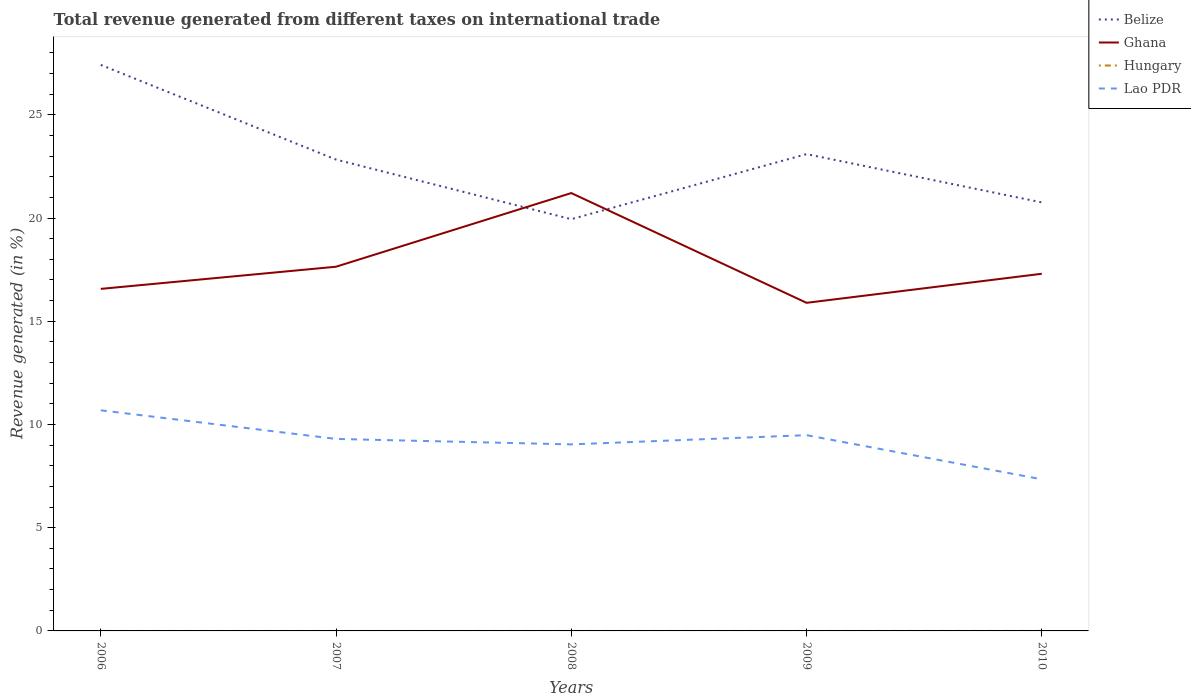Is the number of lines equal to the number of legend labels?
Your answer should be compact. No. Across all years, what is the maximum total revenue generated in Belize?
Make the answer very short. 19.94. What is the total total revenue generated in Lao PDR in the graph?
Provide a short and direct response. 1.96. What is the difference between the highest and the second highest total revenue generated in Belize?
Your answer should be very brief. 7.47. How many lines are there?
Provide a short and direct response. 3. Are the values on the major ticks of Y-axis written in scientific E-notation?
Your answer should be very brief. No. Does the graph contain any zero values?
Your answer should be compact. Yes. Does the graph contain grids?
Your answer should be compact. No. Where does the legend appear in the graph?
Offer a very short reply. Top right. How many legend labels are there?
Keep it short and to the point. 4. How are the legend labels stacked?
Your response must be concise. Vertical. What is the title of the graph?
Your answer should be very brief. Total revenue generated from different taxes on international trade. Does "Algeria" appear as one of the legend labels in the graph?
Provide a succinct answer. No. What is the label or title of the Y-axis?
Offer a very short reply. Revenue generated (in %). What is the Revenue generated (in %) of Belize in 2006?
Your answer should be very brief. 27.42. What is the Revenue generated (in %) in Ghana in 2006?
Your answer should be compact. 16.57. What is the Revenue generated (in %) of Lao PDR in 2006?
Your answer should be very brief. 10.69. What is the Revenue generated (in %) of Belize in 2007?
Provide a succinct answer. 22.83. What is the Revenue generated (in %) of Ghana in 2007?
Offer a very short reply. 17.64. What is the Revenue generated (in %) of Hungary in 2007?
Provide a succinct answer. 0. What is the Revenue generated (in %) in Lao PDR in 2007?
Provide a succinct answer. 9.3. What is the Revenue generated (in %) in Belize in 2008?
Offer a very short reply. 19.94. What is the Revenue generated (in %) of Ghana in 2008?
Provide a short and direct response. 21.21. What is the Revenue generated (in %) in Lao PDR in 2008?
Offer a terse response. 9.04. What is the Revenue generated (in %) of Belize in 2009?
Your answer should be very brief. 23.1. What is the Revenue generated (in %) in Ghana in 2009?
Make the answer very short. 15.89. What is the Revenue generated (in %) of Hungary in 2009?
Your answer should be very brief. 0. What is the Revenue generated (in %) in Lao PDR in 2009?
Offer a very short reply. 9.48. What is the Revenue generated (in %) in Belize in 2010?
Your response must be concise. 20.76. What is the Revenue generated (in %) in Ghana in 2010?
Your answer should be compact. 17.3. What is the Revenue generated (in %) of Hungary in 2010?
Your answer should be compact. 0. What is the Revenue generated (in %) of Lao PDR in 2010?
Provide a short and direct response. 7.34. Across all years, what is the maximum Revenue generated (in %) in Belize?
Your answer should be very brief. 27.42. Across all years, what is the maximum Revenue generated (in %) in Ghana?
Keep it short and to the point. 21.21. Across all years, what is the maximum Revenue generated (in %) in Lao PDR?
Provide a succinct answer. 10.69. Across all years, what is the minimum Revenue generated (in %) of Belize?
Offer a terse response. 19.94. Across all years, what is the minimum Revenue generated (in %) of Ghana?
Keep it short and to the point. 15.89. Across all years, what is the minimum Revenue generated (in %) of Lao PDR?
Make the answer very short. 7.34. What is the total Revenue generated (in %) of Belize in the graph?
Offer a very short reply. 114.04. What is the total Revenue generated (in %) in Ghana in the graph?
Keep it short and to the point. 88.61. What is the total Revenue generated (in %) of Hungary in the graph?
Your response must be concise. 0. What is the total Revenue generated (in %) of Lao PDR in the graph?
Provide a succinct answer. 45.85. What is the difference between the Revenue generated (in %) of Belize in 2006 and that in 2007?
Provide a succinct answer. 4.59. What is the difference between the Revenue generated (in %) of Ghana in 2006 and that in 2007?
Keep it short and to the point. -1.07. What is the difference between the Revenue generated (in %) in Lao PDR in 2006 and that in 2007?
Give a very brief answer. 1.39. What is the difference between the Revenue generated (in %) in Belize in 2006 and that in 2008?
Provide a succinct answer. 7.47. What is the difference between the Revenue generated (in %) of Ghana in 2006 and that in 2008?
Provide a short and direct response. -4.64. What is the difference between the Revenue generated (in %) of Lao PDR in 2006 and that in 2008?
Provide a short and direct response. 1.65. What is the difference between the Revenue generated (in %) in Belize in 2006 and that in 2009?
Provide a succinct answer. 4.32. What is the difference between the Revenue generated (in %) in Ghana in 2006 and that in 2009?
Offer a very short reply. 0.68. What is the difference between the Revenue generated (in %) in Lao PDR in 2006 and that in 2009?
Offer a terse response. 1.2. What is the difference between the Revenue generated (in %) of Belize in 2006 and that in 2010?
Your answer should be compact. 6.66. What is the difference between the Revenue generated (in %) of Ghana in 2006 and that in 2010?
Provide a succinct answer. -0.73. What is the difference between the Revenue generated (in %) in Lao PDR in 2006 and that in 2010?
Ensure brevity in your answer.  3.34. What is the difference between the Revenue generated (in %) of Belize in 2007 and that in 2008?
Give a very brief answer. 2.89. What is the difference between the Revenue generated (in %) of Ghana in 2007 and that in 2008?
Offer a very short reply. -3.57. What is the difference between the Revenue generated (in %) of Lao PDR in 2007 and that in 2008?
Offer a terse response. 0.27. What is the difference between the Revenue generated (in %) of Belize in 2007 and that in 2009?
Offer a very short reply. -0.27. What is the difference between the Revenue generated (in %) in Ghana in 2007 and that in 2009?
Your answer should be compact. 1.75. What is the difference between the Revenue generated (in %) in Lao PDR in 2007 and that in 2009?
Your answer should be compact. -0.18. What is the difference between the Revenue generated (in %) in Belize in 2007 and that in 2010?
Your answer should be very brief. 2.07. What is the difference between the Revenue generated (in %) of Ghana in 2007 and that in 2010?
Your response must be concise. 0.34. What is the difference between the Revenue generated (in %) in Lao PDR in 2007 and that in 2010?
Provide a short and direct response. 1.96. What is the difference between the Revenue generated (in %) of Belize in 2008 and that in 2009?
Provide a succinct answer. -3.15. What is the difference between the Revenue generated (in %) of Ghana in 2008 and that in 2009?
Give a very brief answer. 5.32. What is the difference between the Revenue generated (in %) in Lao PDR in 2008 and that in 2009?
Keep it short and to the point. -0.45. What is the difference between the Revenue generated (in %) in Belize in 2008 and that in 2010?
Your answer should be compact. -0.81. What is the difference between the Revenue generated (in %) of Ghana in 2008 and that in 2010?
Keep it short and to the point. 3.91. What is the difference between the Revenue generated (in %) in Lao PDR in 2008 and that in 2010?
Your answer should be very brief. 1.69. What is the difference between the Revenue generated (in %) in Belize in 2009 and that in 2010?
Provide a short and direct response. 2.34. What is the difference between the Revenue generated (in %) of Ghana in 2009 and that in 2010?
Offer a very short reply. -1.41. What is the difference between the Revenue generated (in %) in Lao PDR in 2009 and that in 2010?
Offer a terse response. 2.14. What is the difference between the Revenue generated (in %) of Belize in 2006 and the Revenue generated (in %) of Ghana in 2007?
Ensure brevity in your answer.  9.78. What is the difference between the Revenue generated (in %) in Belize in 2006 and the Revenue generated (in %) in Lao PDR in 2007?
Your answer should be very brief. 18.12. What is the difference between the Revenue generated (in %) of Ghana in 2006 and the Revenue generated (in %) of Lao PDR in 2007?
Your response must be concise. 7.27. What is the difference between the Revenue generated (in %) of Belize in 2006 and the Revenue generated (in %) of Ghana in 2008?
Give a very brief answer. 6.21. What is the difference between the Revenue generated (in %) in Belize in 2006 and the Revenue generated (in %) in Lao PDR in 2008?
Keep it short and to the point. 18.38. What is the difference between the Revenue generated (in %) in Ghana in 2006 and the Revenue generated (in %) in Lao PDR in 2008?
Ensure brevity in your answer.  7.53. What is the difference between the Revenue generated (in %) of Belize in 2006 and the Revenue generated (in %) of Ghana in 2009?
Offer a terse response. 11.53. What is the difference between the Revenue generated (in %) of Belize in 2006 and the Revenue generated (in %) of Lao PDR in 2009?
Offer a terse response. 17.94. What is the difference between the Revenue generated (in %) in Ghana in 2006 and the Revenue generated (in %) in Lao PDR in 2009?
Provide a short and direct response. 7.09. What is the difference between the Revenue generated (in %) in Belize in 2006 and the Revenue generated (in %) in Ghana in 2010?
Your response must be concise. 10.12. What is the difference between the Revenue generated (in %) of Belize in 2006 and the Revenue generated (in %) of Lao PDR in 2010?
Ensure brevity in your answer.  20.07. What is the difference between the Revenue generated (in %) in Ghana in 2006 and the Revenue generated (in %) in Lao PDR in 2010?
Offer a very short reply. 9.22. What is the difference between the Revenue generated (in %) in Belize in 2007 and the Revenue generated (in %) in Ghana in 2008?
Ensure brevity in your answer.  1.62. What is the difference between the Revenue generated (in %) in Belize in 2007 and the Revenue generated (in %) in Lao PDR in 2008?
Your answer should be compact. 13.8. What is the difference between the Revenue generated (in %) in Ghana in 2007 and the Revenue generated (in %) in Lao PDR in 2008?
Your answer should be very brief. 8.61. What is the difference between the Revenue generated (in %) of Belize in 2007 and the Revenue generated (in %) of Ghana in 2009?
Keep it short and to the point. 6.94. What is the difference between the Revenue generated (in %) in Belize in 2007 and the Revenue generated (in %) in Lao PDR in 2009?
Your answer should be compact. 13.35. What is the difference between the Revenue generated (in %) of Ghana in 2007 and the Revenue generated (in %) of Lao PDR in 2009?
Provide a succinct answer. 8.16. What is the difference between the Revenue generated (in %) in Belize in 2007 and the Revenue generated (in %) in Ghana in 2010?
Your answer should be very brief. 5.53. What is the difference between the Revenue generated (in %) of Belize in 2007 and the Revenue generated (in %) of Lao PDR in 2010?
Your answer should be very brief. 15.49. What is the difference between the Revenue generated (in %) in Ghana in 2007 and the Revenue generated (in %) in Lao PDR in 2010?
Your answer should be compact. 10.3. What is the difference between the Revenue generated (in %) in Belize in 2008 and the Revenue generated (in %) in Ghana in 2009?
Provide a short and direct response. 4.05. What is the difference between the Revenue generated (in %) in Belize in 2008 and the Revenue generated (in %) in Lao PDR in 2009?
Your response must be concise. 10.46. What is the difference between the Revenue generated (in %) in Ghana in 2008 and the Revenue generated (in %) in Lao PDR in 2009?
Provide a short and direct response. 11.73. What is the difference between the Revenue generated (in %) of Belize in 2008 and the Revenue generated (in %) of Ghana in 2010?
Give a very brief answer. 2.64. What is the difference between the Revenue generated (in %) of Belize in 2008 and the Revenue generated (in %) of Lao PDR in 2010?
Offer a terse response. 12.6. What is the difference between the Revenue generated (in %) in Ghana in 2008 and the Revenue generated (in %) in Lao PDR in 2010?
Provide a short and direct response. 13.86. What is the difference between the Revenue generated (in %) in Belize in 2009 and the Revenue generated (in %) in Ghana in 2010?
Your answer should be compact. 5.8. What is the difference between the Revenue generated (in %) in Belize in 2009 and the Revenue generated (in %) in Lao PDR in 2010?
Offer a very short reply. 15.75. What is the difference between the Revenue generated (in %) of Ghana in 2009 and the Revenue generated (in %) of Lao PDR in 2010?
Ensure brevity in your answer.  8.55. What is the average Revenue generated (in %) in Belize per year?
Make the answer very short. 22.81. What is the average Revenue generated (in %) in Ghana per year?
Provide a succinct answer. 17.72. What is the average Revenue generated (in %) of Lao PDR per year?
Make the answer very short. 9.17. In the year 2006, what is the difference between the Revenue generated (in %) in Belize and Revenue generated (in %) in Ghana?
Your answer should be compact. 10.85. In the year 2006, what is the difference between the Revenue generated (in %) in Belize and Revenue generated (in %) in Lao PDR?
Ensure brevity in your answer.  16.73. In the year 2006, what is the difference between the Revenue generated (in %) in Ghana and Revenue generated (in %) in Lao PDR?
Your answer should be very brief. 5.88. In the year 2007, what is the difference between the Revenue generated (in %) in Belize and Revenue generated (in %) in Ghana?
Your answer should be very brief. 5.19. In the year 2007, what is the difference between the Revenue generated (in %) of Belize and Revenue generated (in %) of Lao PDR?
Your answer should be compact. 13.53. In the year 2007, what is the difference between the Revenue generated (in %) in Ghana and Revenue generated (in %) in Lao PDR?
Provide a short and direct response. 8.34. In the year 2008, what is the difference between the Revenue generated (in %) of Belize and Revenue generated (in %) of Ghana?
Ensure brevity in your answer.  -1.27. In the year 2008, what is the difference between the Revenue generated (in %) in Belize and Revenue generated (in %) in Lao PDR?
Provide a short and direct response. 10.91. In the year 2008, what is the difference between the Revenue generated (in %) in Ghana and Revenue generated (in %) in Lao PDR?
Your answer should be very brief. 12.17. In the year 2009, what is the difference between the Revenue generated (in %) of Belize and Revenue generated (in %) of Ghana?
Your answer should be compact. 7.2. In the year 2009, what is the difference between the Revenue generated (in %) in Belize and Revenue generated (in %) in Lao PDR?
Ensure brevity in your answer.  13.61. In the year 2009, what is the difference between the Revenue generated (in %) of Ghana and Revenue generated (in %) of Lao PDR?
Keep it short and to the point. 6.41. In the year 2010, what is the difference between the Revenue generated (in %) in Belize and Revenue generated (in %) in Ghana?
Keep it short and to the point. 3.46. In the year 2010, what is the difference between the Revenue generated (in %) of Belize and Revenue generated (in %) of Lao PDR?
Provide a succinct answer. 13.41. In the year 2010, what is the difference between the Revenue generated (in %) in Ghana and Revenue generated (in %) in Lao PDR?
Your response must be concise. 9.96. What is the ratio of the Revenue generated (in %) in Belize in 2006 to that in 2007?
Offer a very short reply. 1.2. What is the ratio of the Revenue generated (in %) of Ghana in 2006 to that in 2007?
Offer a very short reply. 0.94. What is the ratio of the Revenue generated (in %) in Lao PDR in 2006 to that in 2007?
Your response must be concise. 1.15. What is the ratio of the Revenue generated (in %) in Belize in 2006 to that in 2008?
Keep it short and to the point. 1.37. What is the ratio of the Revenue generated (in %) of Ghana in 2006 to that in 2008?
Provide a succinct answer. 0.78. What is the ratio of the Revenue generated (in %) in Lao PDR in 2006 to that in 2008?
Keep it short and to the point. 1.18. What is the ratio of the Revenue generated (in %) of Belize in 2006 to that in 2009?
Keep it short and to the point. 1.19. What is the ratio of the Revenue generated (in %) of Ghana in 2006 to that in 2009?
Your answer should be compact. 1.04. What is the ratio of the Revenue generated (in %) of Lao PDR in 2006 to that in 2009?
Your answer should be compact. 1.13. What is the ratio of the Revenue generated (in %) of Belize in 2006 to that in 2010?
Your response must be concise. 1.32. What is the ratio of the Revenue generated (in %) in Ghana in 2006 to that in 2010?
Provide a short and direct response. 0.96. What is the ratio of the Revenue generated (in %) in Lao PDR in 2006 to that in 2010?
Give a very brief answer. 1.45. What is the ratio of the Revenue generated (in %) in Belize in 2007 to that in 2008?
Provide a succinct answer. 1.14. What is the ratio of the Revenue generated (in %) of Ghana in 2007 to that in 2008?
Make the answer very short. 0.83. What is the ratio of the Revenue generated (in %) of Lao PDR in 2007 to that in 2008?
Keep it short and to the point. 1.03. What is the ratio of the Revenue generated (in %) in Belize in 2007 to that in 2009?
Provide a succinct answer. 0.99. What is the ratio of the Revenue generated (in %) of Ghana in 2007 to that in 2009?
Your answer should be compact. 1.11. What is the ratio of the Revenue generated (in %) of Lao PDR in 2007 to that in 2009?
Offer a terse response. 0.98. What is the ratio of the Revenue generated (in %) in Belize in 2007 to that in 2010?
Make the answer very short. 1.1. What is the ratio of the Revenue generated (in %) of Ghana in 2007 to that in 2010?
Give a very brief answer. 1.02. What is the ratio of the Revenue generated (in %) in Lao PDR in 2007 to that in 2010?
Provide a succinct answer. 1.27. What is the ratio of the Revenue generated (in %) of Belize in 2008 to that in 2009?
Make the answer very short. 0.86. What is the ratio of the Revenue generated (in %) in Ghana in 2008 to that in 2009?
Offer a terse response. 1.33. What is the ratio of the Revenue generated (in %) of Lao PDR in 2008 to that in 2009?
Your answer should be very brief. 0.95. What is the ratio of the Revenue generated (in %) in Belize in 2008 to that in 2010?
Your answer should be very brief. 0.96. What is the ratio of the Revenue generated (in %) in Ghana in 2008 to that in 2010?
Provide a succinct answer. 1.23. What is the ratio of the Revenue generated (in %) of Lao PDR in 2008 to that in 2010?
Offer a very short reply. 1.23. What is the ratio of the Revenue generated (in %) of Belize in 2009 to that in 2010?
Your answer should be compact. 1.11. What is the ratio of the Revenue generated (in %) of Ghana in 2009 to that in 2010?
Offer a terse response. 0.92. What is the ratio of the Revenue generated (in %) of Lao PDR in 2009 to that in 2010?
Provide a succinct answer. 1.29. What is the difference between the highest and the second highest Revenue generated (in %) in Belize?
Provide a succinct answer. 4.32. What is the difference between the highest and the second highest Revenue generated (in %) in Ghana?
Ensure brevity in your answer.  3.57. What is the difference between the highest and the second highest Revenue generated (in %) of Lao PDR?
Your answer should be very brief. 1.2. What is the difference between the highest and the lowest Revenue generated (in %) in Belize?
Offer a very short reply. 7.47. What is the difference between the highest and the lowest Revenue generated (in %) in Ghana?
Ensure brevity in your answer.  5.32. What is the difference between the highest and the lowest Revenue generated (in %) of Lao PDR?
Make the answer very short. 3.34. 